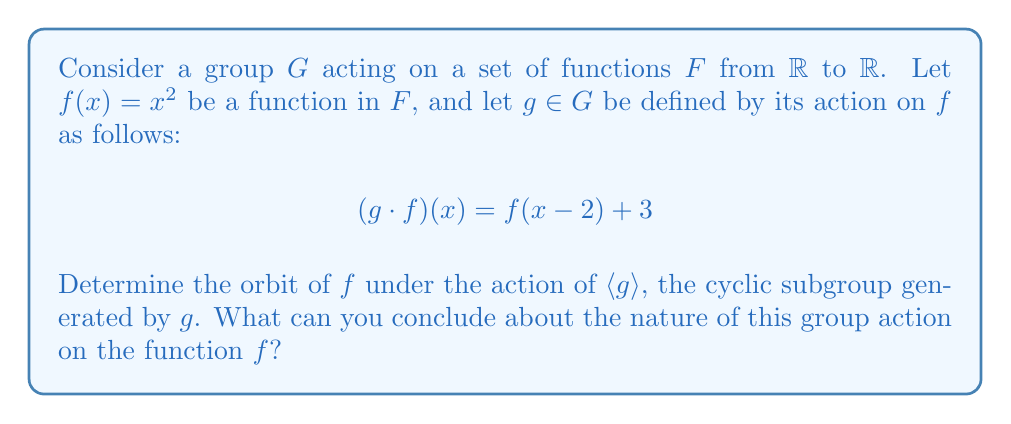Give your solution to this math problem. To solve this problem, we need to analyze the repeated application of $g$ on the function $f(x) = x^2$. Let's proceed step by step:

1) First, let's calculate $g \cdot f$:
   $$(g \cdot f)(x) = f(x-2) + 3 = (x-2)^2 + 3 = x^2 - 4x + 7$$

2) Now, let's calculate $g^2 \cdot f = g \cdot (g \cdot f)$:
   $$\begin{align*}
   (g^2 \cdot f)(x) &= g \cdot (x^2 - 4x + 7) \\
   &= (x-2)^2 - 4(x-2) + 7 + 3 \\
   &= x^2 - 4x + 4 - 4x + 8 + 7 + 3 \\
   &= x^2 - 8x + 22
   \end{align*}$$

3) Continuing this pattern, we can see that each application of $g$ will result in a quadratic function of the form $ax^2 + bx + c$, where:
   - $a$ always remains 1
   - $b$ decreases by 4 each time
   - $c$ increases by a varying amount each time

4) The general form after $n$ applications of $g$ will be:
   $$(g^n \cdot f)(x) = x^2 - 4nx + (4n^2 + 3n)$$

5) This pattern continues indefinitely, producing a distinct function for each integer $n$.

6) The orbit of $f$ under the action of $\langle g \rangle$ is the set of all these functions:
   $$\text{Orbit}_{\langle g \rangle}(f) = \{x^2 - 4nx + (4n^2 + 3n) \mid n \in \mathbb{Z}\}$$

7) This orbit is infinite, as there is a distinct function for each integer $n$.

8) The action of $g$ on $f$ is free, meaning that $g^n \cdot f = f$ only when $n = 0$, or in other words, only the identity element of $\langle g \rangle$ fixes $f$.

9) The action is also faithful, as different elements of $\langle g \rangle$ produce different results when acting on $f$.
Answer: The orbit of $f(x) = x^2$ under the action of $\langle g \rangle$ is the infinite set $\{x^2 - 4nx + (4n^2 + 3n) \mid n \in \mathbb{Z}\}$. The group action is both free and faithful on $f$. 